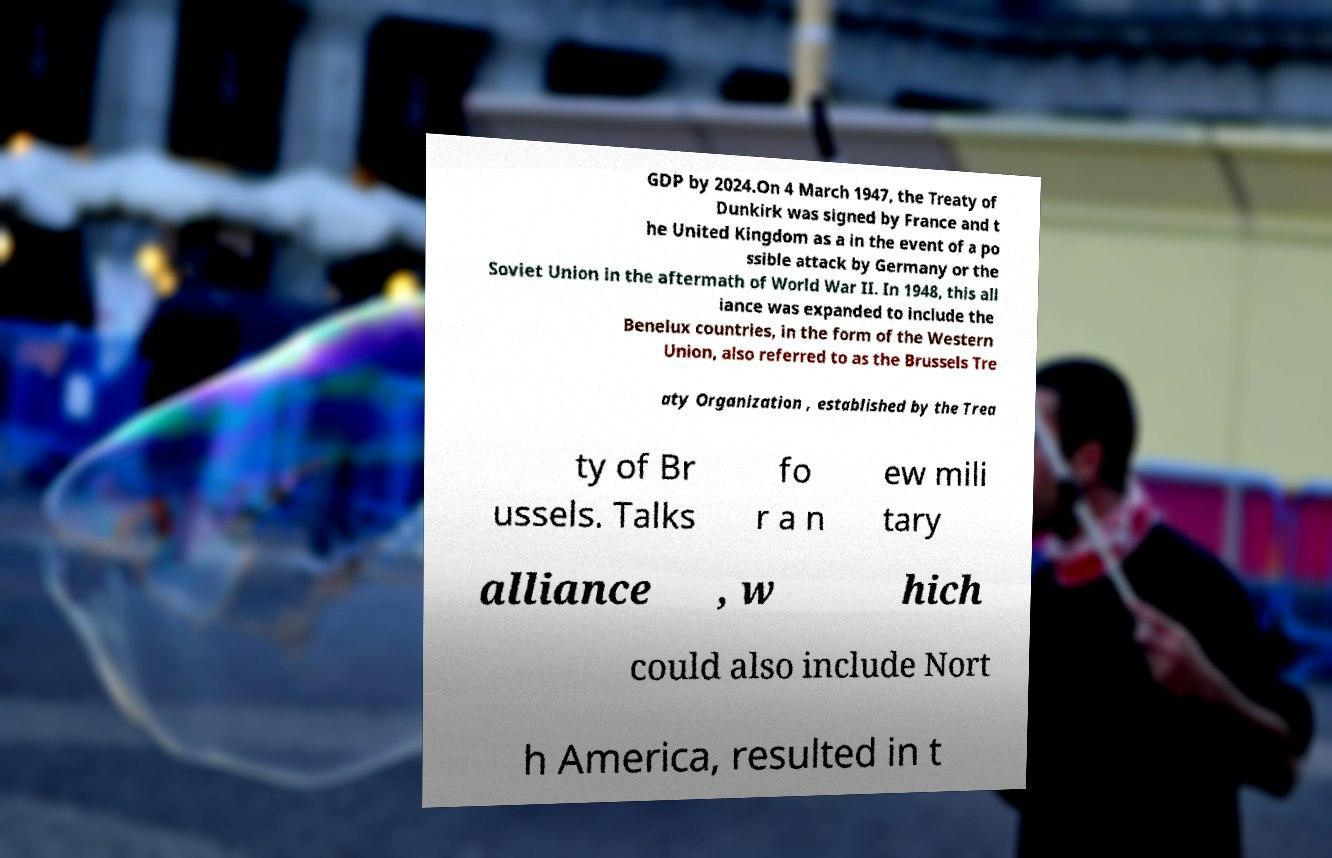Please identify and transcribe the text found in this image. GDP by 2024.On 4 March 1947, the Treaty of Dunkirk was signed by France and t he United Kingdom as a in the event of a po ssible attack by Germany or the Soviet Union in the aftermath of World War II. In 1948, this all iance was expanded to include the Benelux countries, in the form of the Western Union, also referred to as the Brussels Tre aty Organization , established by the Trea ty of Br ussels. Talks fo r a n ew mili tary alliance , w hich could also include Nort h America, resulted in t 